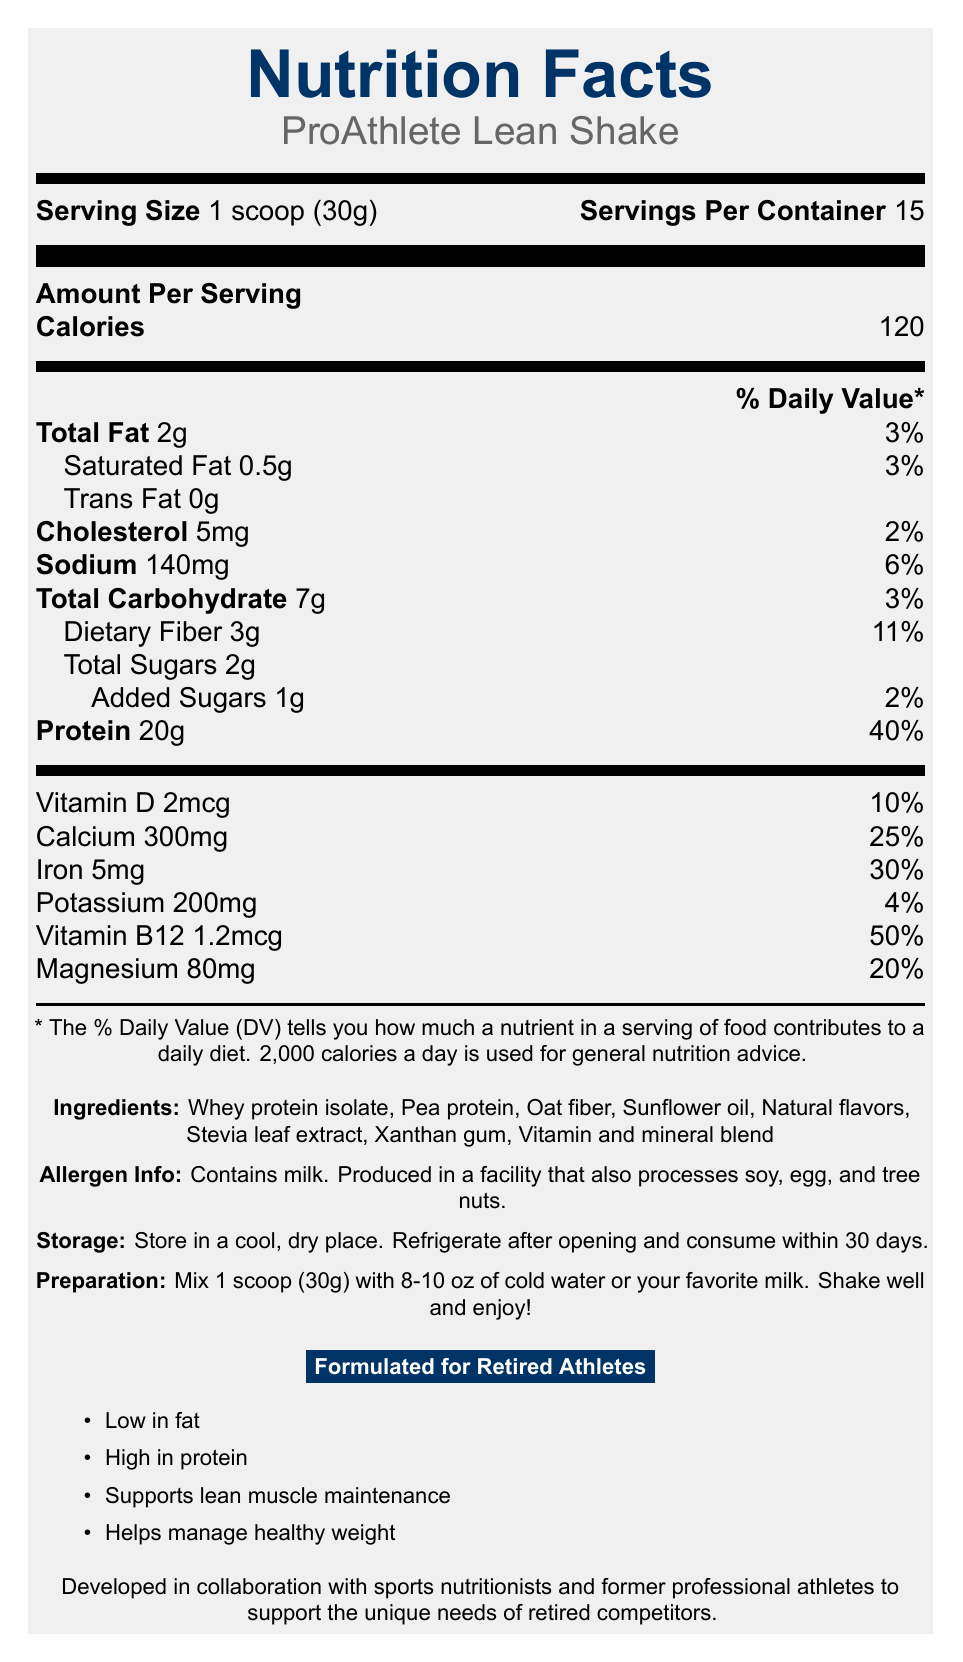What is the serving size of ProAthlete Lean Shake? The document specifies the serving size as 1 scoop (30g).
Answer: 1 scoop (30g) How many servings are there in a container of ProAthlete Lean Shake? The document lists 15 servings per container.
Answer: 15 What is the total fat content per serving in ProAthlete Lean Shake? The document lists the total fat content as 2g per serving.
Answer: 2g What is the amount of protein per serving in ProAthlete Lean Shake? The document states that each serving contains 20g of protein.
Answer: 20g What is the daily value percentage of iron per serving? The document states that the daily value percentage for iron is 30%.
Answer: 30% Which ingredient is not present in ProAthlete Lean Shake? A. Pea protein B. Cocoa powder C. Oat fiber D. Stevia leaf extract The list of ingredients does not include cocoa powder.
Answer: B. Cocoa powder ProAthlete Lean Shake is specially formulated for which group of individuals? A. Marathon runners B. Bodybuilders C. Retired athletes D. College students The document specifies that the shake is formulated for retired athletes.
Answer: C. Retired athletes What needs to be done after opening the container of ProAthlete Lean Shake? A. Store in a dark place B. Consume within 15 days C. Refrigerate D. Freeze The storage instructions indicate that the product should be refrigerated after opening.
Answer: C. Refrigerate Does the ProAthlete Lean Shake contain any trans fat? The document lists trans fat content as 0g, indicating there is no trans fat.
Answer: No Summarize the main claims and features of ProAthlete Lean Shake. The ProAthlete Lean Shake is designed with specific nutritional requirements for retired athletes, focusing on low fat and high protein content to support muscle maintenance and weight management. The shake contains essential vitamins and minerals, and specific storage and preparation instructions ensure proper use.
Answer: The ProAthlete Lean Shake is a low-fat, high-protein meal replacement designed for weight management in retired athletes. It contains 120 calories, 20g of protein, and 2g of total fat per serving. Key benefits include supporting lean muscle maintenance and managing healthy weight. Ingredients include whey protein isolate and pea protein. It also includes essential vitamins and minerals, and should be refrigerated after opening. What is the preparation instruction for ProAthlete Lean Shake? The document provides clear preparation instructions, stating to mix 1 scoop (30g) with 8-10 oz of cold water or milk and shake well.
Answer: Mix 1 scoop (30g) with 8-10 oz of cold water or your favorite milk. Shake well and enjoy! What is the percentage of daily value for Vitamin D in each serving of ProAthlete Lean Shake? The document lists the daily value for Vitamin D as 10%.
Answer: 10% How much dietary fiber is present in each serving? The dietary fiber content per serving is listed as 3g.
Answer: 3g Can you determine the price of ProAthlete Lean Shake from the document? The document does not contain any information regarding the price of ProAthlete Lean Shake.
Answer: Cannot be determined 